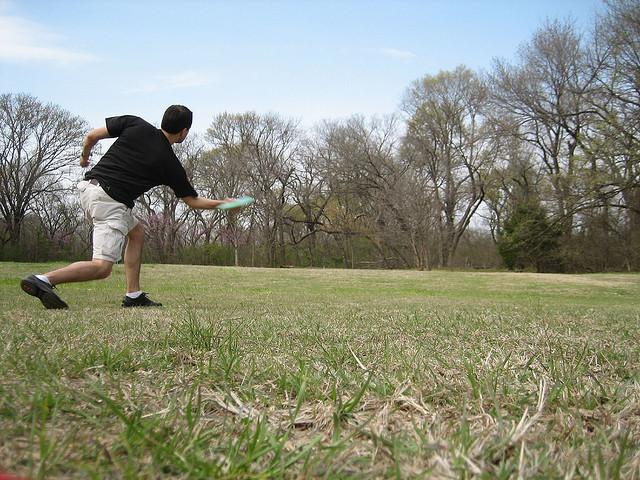Is the human wear long pants and a blue coat?
Write a very short answer. No. What is in the background scenery?
Write a very short answer. Trees. Is the guy throwing something?
Give a very brief answer. Yes. 